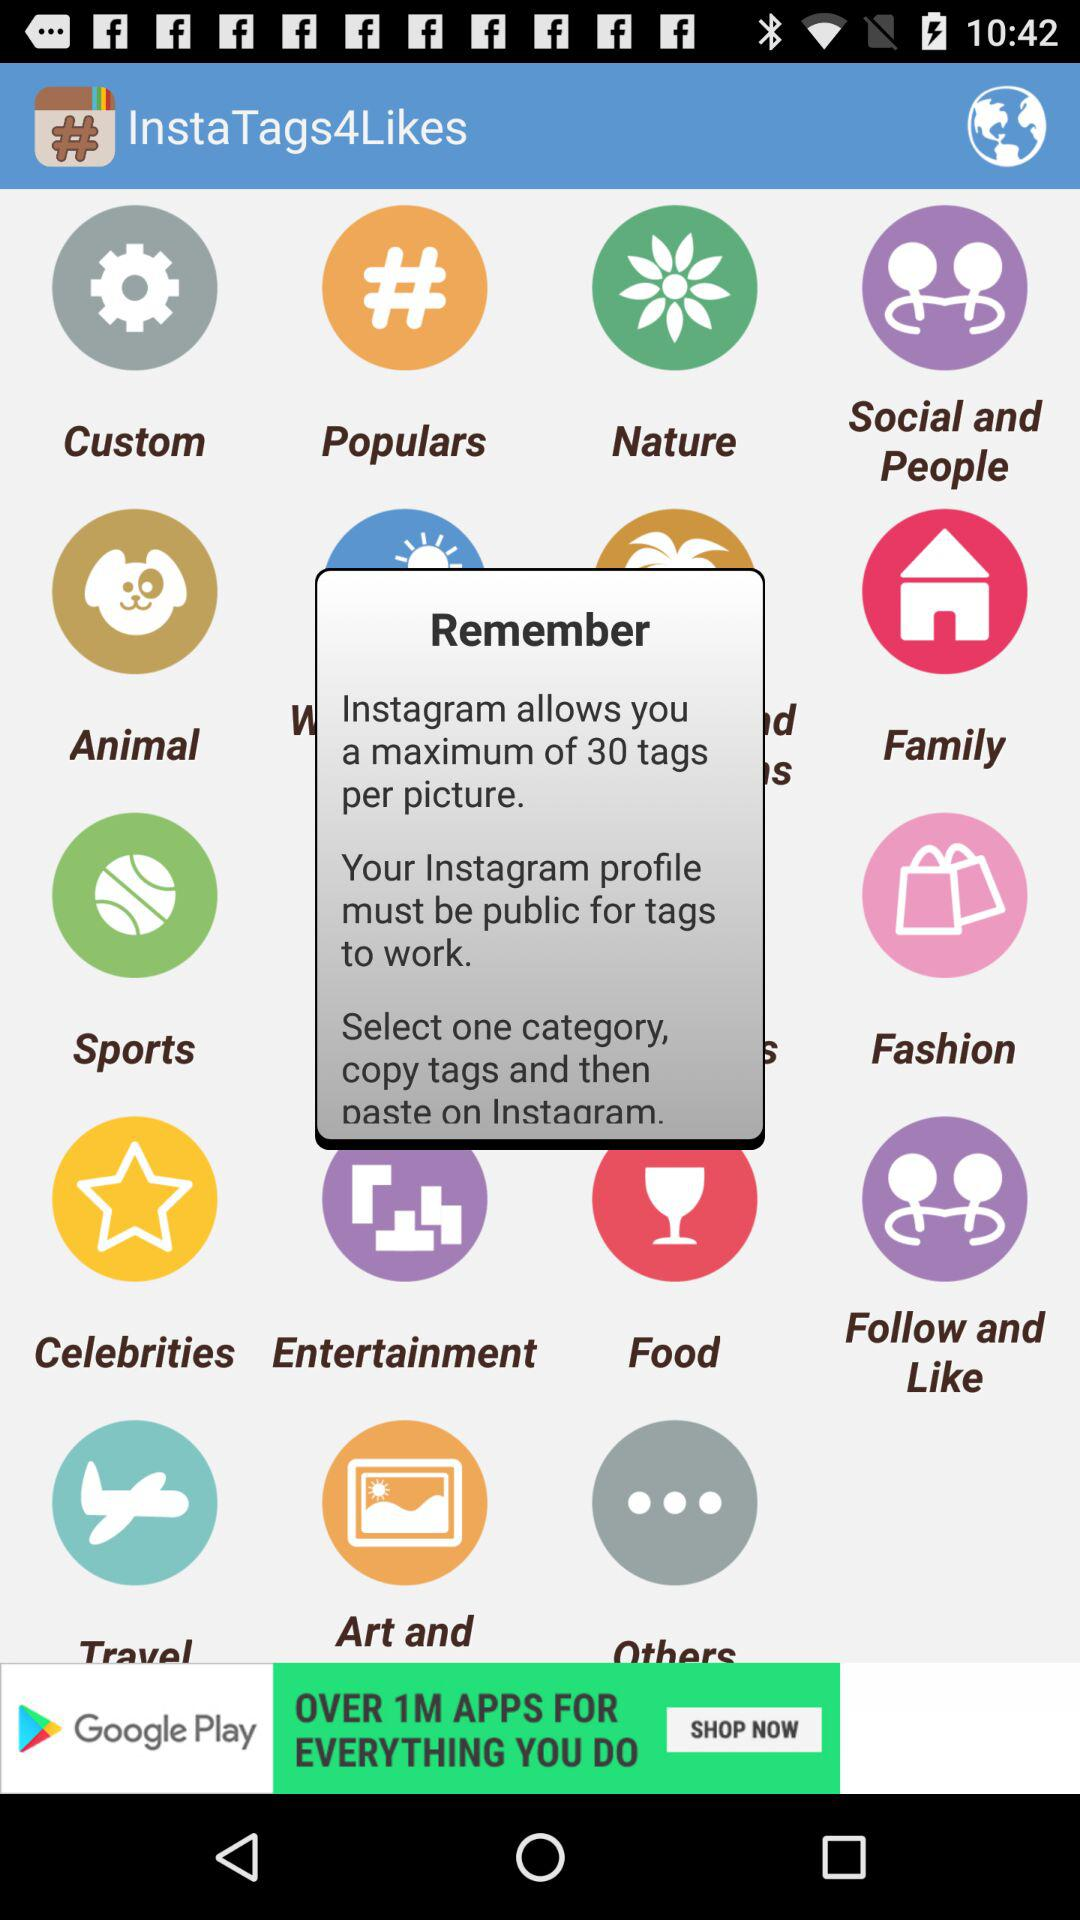What is the maximum limit of tags per picture? The maximum limit of tags per picture is 30. 